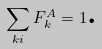Convert formula to latex. <formula><loc_0><loc_0><loc_500><loc_500>\sum _ { k i } F _ { k } ^ { A } = 1 \text {.}</formula> 